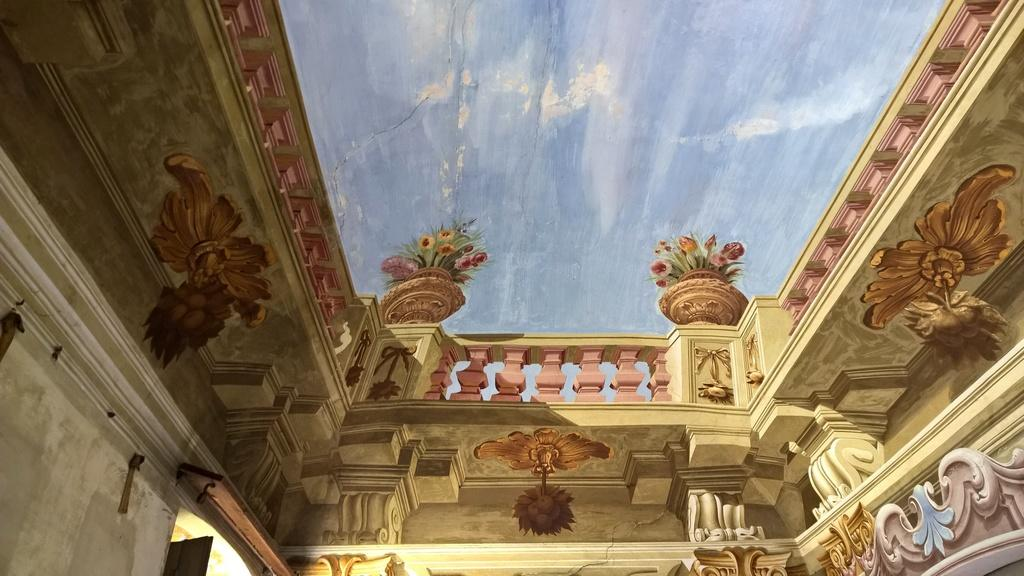What is the main subject of the painting in the image? The painting depicts a building. Are there any additional elements present in the painting? Yes, there are pots on top of the building in the painting. What type of loaf can be seen on the floor in the image? There is no loaf present in the image; it only features a painting of a building with pots on top. 